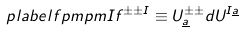Convert formula to latex. <formula><loc_0><loc_0><loc_500><loc_500>\ p l a b e l { f p m p m I } f ^ { \pm \pm I } \equiv U ^ { \pm \pm } _ { \underline { a } } d U ^ { I \underline { a } }</formula> 